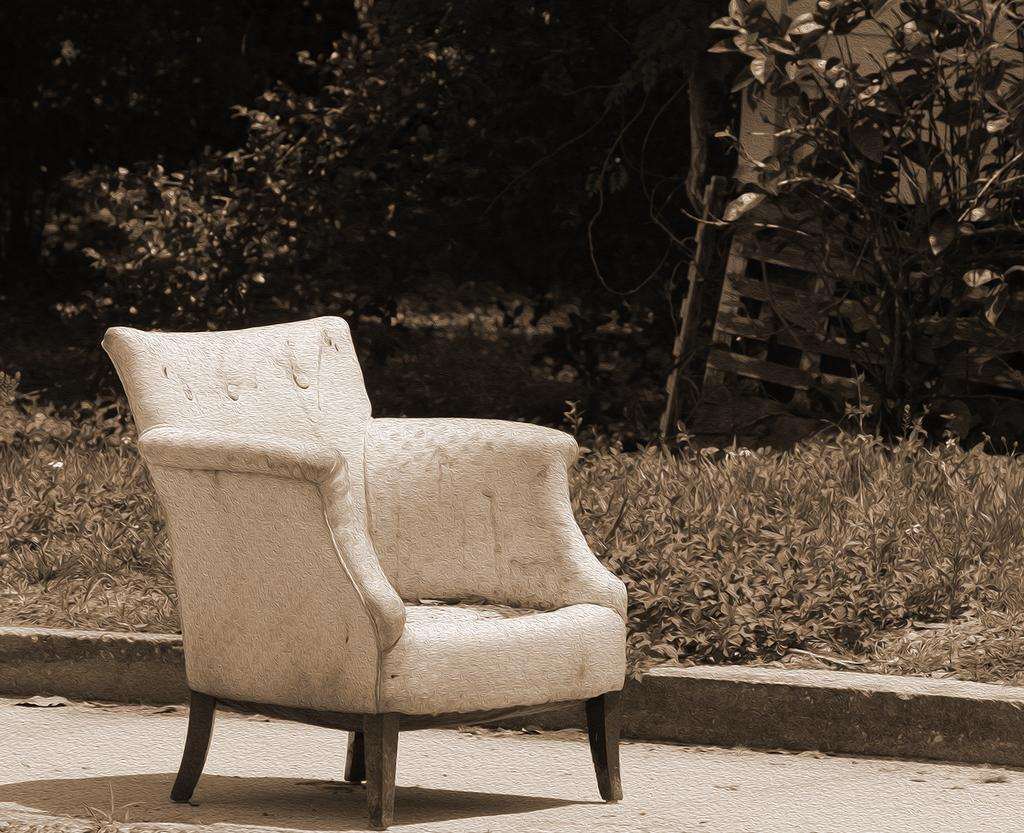What type of furniture is present in the image? There is a chair in the image. What can be seen in the background of the image? There are trees in the image. How many boots are hanging on the chair in the image? There are no boots present in the image; only a chair and trees can be seen. 